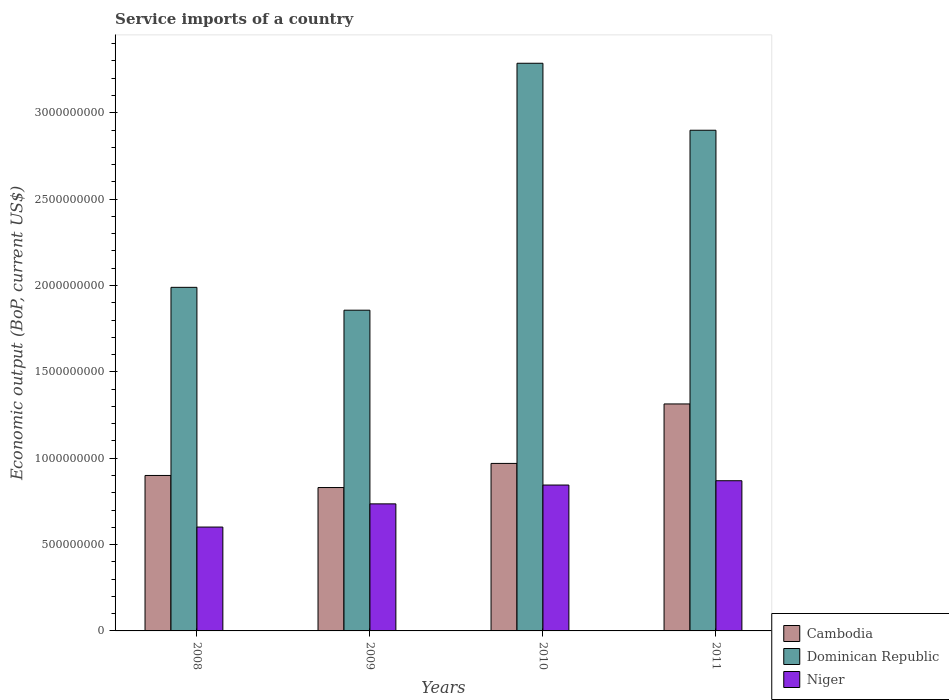How many groups of bars are there?
Make the answer very short. 4. Are the number of bars per tick equal to the number of legend labels?
Ensure brevity in your answer.  Yes. Are the number of bars on each tick of the X-axis equal?
Your answer should be very brief. Yes. How many bars are there on the 2nd tick from the left?
Provide a short and direct response. 3. How many bars are there on the 3rd tick from the right?
Your answer should be very brief. 3. What is the label of the 4th group of bars from the left?
Provide a succinct answer. 2011. What is the service imports in Dominican Republic in 2009?
Keep it short and to the point. 1.86e+09. Across all years, what is the maximum service imports in Dominican Republic?
Your response must be concise. 3.29e+09. Across all years, what is the minimum service imports in Niger?
Make the answer very short. 6.01e+08. In which year was the service imports in Dominican Republic maximum?
Provide a short and direct response. 2010. What is the total service imports in Dominican Republic in the graph?
Keep it short and to the point. 1.00e+1. What is the difference between the service imports in Dominican Republic in 2008 and that in 2009?
Keep it short and to the point. 1.32e+08. What is the difference between the service imports in Cambodia in 2011 and the service imports in Niger in 2009?
Ensure brevity in your answer.  5.79e+08. What is the average service imports in Dominican Republic per year?
Your answer should be compact. 2.51e+09. In the year 2011, what is the difference between the service imports in Cambodia and service imports in Niger?
Provide a short and direct response. 4.45e+08. In how many years, is the service imports in Niger greater than 1100000000 US$?
Make the answer very short. 0. What is the ratio of the service imports in Dominican Republic in 2008 to that in 2010?
Ensure brevity in your answer.  0.61. Is the difference between the service imports in Cambodia in 2008 and 2010 greater than the difference between the service imports in Niger in 2008 and 2010?
Provide a succinct answer. Yes. What is the difference between the highest and the second highest service imports in Dominican Republic?
Your answer should be very brief. 3.88e+08. What is the difference between the highest and the lowest service imports in Cambodia?
Provide a short and direct response. 4.84e+08. In how many years, is the service imports in Niger greater than the average service imports in Niger taken over all years?
Ensure brevity in your answer.  2. Is the sum of the service imports in Niger in 2009 and 2011 greater than the maximum service imports in Dominican Republic across all years?
Offer a terse response. No. What does the 1st bar from the left in 2009 represents?
Keep it short and to the point. Cambodia. What does the 3rd bar from the right in 2011 represents?
Make the answer very short. Cambodia. How many bars are there?
Offer a very short reply. 12. Are all the bars in the graph horizontal?
Give a very brief answer. No. How many years are there in the graph?
Your answer should be very brief. 4. Does the graph contain grids?
Make the answer very short. No. How many legend labels are there?
Your response must be concise. 3. How are the legend labels stacked?
Make the answer very short. Vertical. What is the title of the graph?
Keep it short and to the point. Service imports of a country. What is the label or title of the X-axis?
Give a very brief answer. Years. What is the label or title of the Y-axis?
Your answer should be very brief. Economic output (BoP, current US$). What is the Economic output (BoP, current US$) of Cambodia in 2008?
Your response must be concise. 9.00e+08. What is the Economic output (BoP, current US$) in Dominican Republic in 2008?
Provide a short and direct response. 1.99e+09. What is the Economic output (BoP, current US$) of Niger in 2008?
Offer a very short reply. 6.01e+08. What is the Economic output (BoP, current US$) of Cambodia in 2009?
Keep it short and to the point. 8.30e+08. What is the Economic output (BoP, current US$) of Dominican Republic in 2009?
Your answer should be compact. 1.86e+09. What is the Economic output (BoP, current US$) of Niger in 2009?
Make the answer very short. 7.36e+08. What is the Economic output (BoP, current US$) of Cambodia in 2010?
Make the answer very short. 9.70e+08. What is the Economic output (BoP, current US$) of Dominican Republic in 2010?
Your answer should be very brief. 3.29e+09. What is the Economic output (BoP, current US$) in Niger in 2010?
Provide a short and direct response. 8.45e+08. What is the Economic output (BoP, current US$) of Cambodia in 2011?
Your response must be concise. 1.31e+09. What is the Economic output (BoP, current US$) of Dominican Republic in 2011?
Make the answer very short. 2.90e+09. What is the Economic output (BoP, current US$) in Niger in 2011?
Give a very brief answer. 8.70e+08. Across all years, what is the maximum Economic output (BoP, current US$) of Cambodia?
Your answer should be compact. 1.31e+09. Across all years, what is the maximum Economic output (BoP, current US$) in Dominican Republic?
Ensure brevity in your answer.  3.29e+09. Across all years, what is the maximum Economic output (BoP, current US$) in Niger?
Offer a terse response. 8.70e+08. Across all years, what is the minimum Economic output (BoP, current US$) of Cambodia?
Ensure brevity in your answer.  8.30e+08. Across all years, what is the minimum Economic output (BoP, current US$) of Dominican Republic?
Offer a terse response. 1.86e+09. Across all years, what is the minimum Economic output (BoP, current US$) in Niger?
Your answer should be compact. 6.01e+08. What is the total Economic output (BoP, current US$) in Cambodia in the graph?
Offer a terse response. 4.01e+09. What is the total Economic output (BoP, current US$) of Dominican Republic in the graph?
Keep it short and to the point. 1.00e+1. What is the total Economic output (BoP, current US$) in Niger in the graph?
Offer a very short reply. 3.05e+09. What is the difference between the Economic output (BoP, current US$) in Cambodia in 2008 and that in 2009?
Your response must be concise. 6.99e+07. What is the difference between the Economic output (BoP, current US$) of Dominican Republic in 2008 and that in 2009?
Give a very brief answer. 1.32e+08. What is the difference between the Economic output (BoP, current US$) in Niger in 2008 and that in 2009?
Your response must be concise. -1.34e+08. What is the difference between the Economic output (BoP, current US$) in Cambodia in 2008 and that in 2010?
Ensure brevity in your answer.  -6.98e+07. What is the difference between the Economic output (BoP, current US$) in Dominican Republic in 2008 and that in 2010?
Offer a terse response. -1.30e+09. What is the difference between the Economic output (BoP, current US$) of Niger in 2008 and that in 2010?
Ensure brevity in your answer.  -2.43e+08. What is the difference between the Economic output (BoP, current US$) in Cambodia in 2008 and that in 2011?
Your answer should be compact. -4.14e+08. What is the difference between the Economic output (BoP, current US$) of Dominican Republic in 2008 and that in 2011?
Keep it short and to the point. -9.10e+08. What is the difference between the Economic output (BoP, current US$) of Niger in 2008 and that in 2011?
Your answer should be compact. -2.68e+08. What is the difference between the Economic output (BoP, current US$) of Cambodia in 2009 and that in 2010?
Keep it short and to the point. -1.40e+08. What is the difference between the Economic output (BoP, current US$) in Dominican Republic in 2009 and that in 2010?
Provide a succinct answer. -1.43e+09. What is the difference between the Economic output (BoP, current US$) of Niger in 2009 and that in 2010?
Give a very brief answer. -1.09e+08. What is the difference between the Economic output (BoP, current US$) in Cambodia in 2009 and that in 2011?
Make the answer very short. -4.84e+08. What is the difference between the Economic output (BoP, current US$) of Dominican Republic in 2009 and that in 2011?
Offer a very short reply. -1.04e+09. What is the difference between the Economic output (BoP, current US$) in Niger in 2009 and that in 2011?
Offer a very short reply. -1.34e+08. What is the difference between the Economic output (BoP, current US$) in Cambodia in 2010 and that in 2011?
Provide a succinct answer. -3.44e+08. What is the difference between the Economic output (BoP, current US$) in Dominican Republic in 2010 and that in 2011?
Give a very brief answer. 3.88e+08. What is the difference between the Economic output (BoP, current US$) in Niger in 2010 and that in 2011?
Offer a very short reply. -2.49e+07. What is the difference between the Economic output (BoP, current US$) in Cambodia in 2008 and the Economic output (BoP, current US$) in Dominican Republic in 2009?
Your answer should be very brief. -9.57e+08. What is the difference between the Economic output (BoP, current US$) of Cambodia in 2008 and the Economic output (BoP, current US$) of Niger in 2009?
Your response must be concise. 1.64e+08. What is the difference between the Economic output (BoP, current US$) of Dominican Republic in 2008 and the Economic output (BoP, current US$) of Niger in 2009?
Make the answer very short. 1.25e+09. What is the difference between the Economic output (BoP, current US$) of Cambodia in 2008 and the Economic output (BoP, current US$) of Dominican Republic in 2010?
Your answer should be compact. -2.39e+09. What is the difference between the Economic output (BoP, current US$) of Cambodia in 2008 and the Economic output (BoP, current US$) of Niger in 2010?
Provide a short and direct response. 5.54e+07. What is the difference between the Economic output (BoP, current US$) of Dominican Republic in 2008 and the Economic output (BoP, current US$) of Niger in 2010?
Your answer should be compact. 1.14e+09. What is the difference between the Economic output (BoP, current US$) in Cambodia in 2008 and the Economic output (BoP, current US$) in Dominican Republic in 2011?
Provide a short and direct response. -2.00e+09. What is the difference between the Economic output (BoP, current US$) in Cambodia in 2008 and the Economic output (BoP, current US$) in Niger in 2011?
Your answer should be compact. 3.05e+07. What is the difference between the Economic output (BoP, current US$) in Dominican Republic in 2008 and the Economic output (BoP, current US$) in Niger in 2011?
Make the answer very short. 1.12e+09. What is the difference between the Economic output (BoP, current US$) of Cambodia in 2009 and the Economic output (BoP, current US$) of Dominican Republic in 2010?
Keep it short and to the point. -2.46e+09. What is the difference between the Economic output (BoP, current US$) in Cambodia in 2009 and the Economic output (BoP, current US$) in Niger in 2010?
Your answer should be very brief. -1.45e+07. What is the difference between the Economic output (BoP, current US$) of Dominican Republic in 2009 and the Economic output (BoP, current US$) of Niger in 2010?
Provide a succinct answer. 1.01e+09. What is the difference between the Economic output (BoP, current US$) in Cambodia in 2009 and the Economic output (BoP, current US$) in Dominican Republic in 2011?
Provide a succinct answer. -2.07e+09. What is the difference between the Economic output (BoP, current US$) in Cambodia in 2009 and the Economic output (BoP, current US$) in Niger in 2011?
Offer a very short reply. -3.94e+07. What is the difference between the Economic output (BoP, current US$) of Dominican Republic in 2009 and the Economic output (BoP, current US$) of Niger in 2011?
Give a very brief answer. 9.87e+08. What is the difference between the Economic output (BoP, current US$) of Cambodia in 2010 and the Economic output (BoP, current US$) of Dominican Republic in 2011?
Offer a terse response. -1.93e+09. What is the difference between the Economic output (BoP, current US$) in Cambodia in 2010 and the Economic output (BoP, current US$) in Niger in 2011?
Give a very brief answer. 1.00e+08. What is the difference between the Economic output (BoP, current US$) in Dominican Republic in 2010 and the Economic output (BoP, current US$) in Niger in 2011?
Offer a terse response. 2.42e+09. What is the average Economic output (BoP, current US$) of Cambodia per year?
Provide a short and direct response. 1.00e+09. What is the average Economic output (BoP, current US$) in Dominican Republic per year?
Provide a succinct answer. 2.51e+09. What is the average Economic output (BoP, current US$) in Niger per year?
Keep it short and to the point. 7.63e+08. In the year 2008, what is the difference between the Economic output (BoP, current US$) of Cambodia and Economic output (BoP, current US$) of Dominican Republic?
Ensure brevity in your answer.  -1.09e+09. In the year 2008, what is the difference between the Economic output (BoP, current US$) of Cambodia and Economic output (BoP, current US$) of Niger?
Offer a very short reply. 2.99e+08. In the year 2008, what is the difference between the Economic output (BoP, current US$) in Dominican Republic and Economic output (BoP, current US$) in Niger?
Your response must be concise. 1.39e+09. In the year 2009, what is the difference between the Economic output (BoP, current US$) of Cambodia and Economic output (BoP, current US$) of Dominican Republic?
Offer a terse response. -1.03e+09. In the year 2009, what is the difference between the Economic output (BoP, current US$) of Cambodia and Economic output (BoP, current US$) of Niger?
Make the answer very short. 9.46e+07. In the year 2009, what is the difference between the Economic output (BoP, current US$) of Dominican Republic and Economic output (BoP, current US$) of Niger?
Offer a very short reply. 1.12e+09. In the year 2010, what is the difference between the Economic output (BoP, current US$) in Cambodia and Economic output (BoP, current US$) in Dominican Republic?
Keep it short and to the point. -2.32e+09. In the year 2010, what is the difference between the Economic output (BoP, current US$) in Cambodia and Economic output (BoP, current US$) in Niger?
Your answer should be compact. 1.25e+08. In the year 2010, what is the difference between the Economic output (BoP, current US$) in Dominican Republic and Economic output (BoP, current US$) in Niger?
Provide a short and direct response. 2.44e+09. In the year 2011, what is the difference between the Economic output (BoP, current US$) of Cambodia and Economic output (BoP, current US$) of Dominican Republic?
Keep it short and to the point. -1.58e+09. In the year 2011, what is the difference between the Economic output (BoP, current US$) of Cambodia and Economic output (BoP, current US$) of Niger?
Keep it short and to the point. 4.45e+08. In the year 2011, what is the difference between the Economic output (BoP, current US$) in Dominican Republic and Economic output (BoP, current US$) in Niger?
Keep it short and to the point. 2.03e+09. What is the ratio of the Economic output (BoP, current US$) of Cambodia in 2008 to that in 2009?
Give a very brief answer. 1.08. What is the ratio of the Economic output (BoP, current US$) in Dominican Republic in 2008 to that in 2009?
Your answer should be very brief. 1.07. What is the ratio of the Economic output (BoP, current US$) in Niger in 2008 to that in 2009?
Make the answer very short. 0.82. What is the ratio of the Economic output (BoP, current US$) in Cambodia in 2008 to that in 2010?
Provide a succinct answer. 0.93. What is the ratio of the Economic output (BoP, current US$) in Dominican Republic in 2008 to that in 2010?
Make the answer very short. 0.61. What is the ratio of the Economic output (BoP, current US$) of Niger in 2008 to that in 2010?
Your answer should be very brief. 0.71. What is the ratio of the Economic output (BoP, current US$) of Cambodia in 2008 to that in 2011?
Ensure brevity in your answer.  0.68. What is the ratio of the Economic output (BoP, current US$) in Dominican Republic in 2008 to that in 2011?
Make the answer very short. 0.69. What is the ratio of the Economic output (BoP, current US$) in Niger in 2008 to that in 2011?
Your answer should be very brief. 0.69. What is the ratio of the Economic output (BoP, current US$) of Cambodia in 2009 to that in 2010?
Keep it short and to the point. 0.86. What is the ratio of the Economic output (BoP, current US$) in Dominican Republic in 2009 to that in 2010?
Your response must be concise. 0.56. What is the ratio of the Economic output (BoP, current US$) of Niger in 2009 to that in 2010?
Your answer should be very brief. 0.87. What is the ratio of the Economic output (BoP, current US$) of Cambodia in 2009 to that in 2011?
Keep it short and to the point. 0.63. What is the ratio of the Economic output (BoP, current US$) of Dominican Republic in 2009 to that in 2011?
Provide a succinct answer. 0.64. What is the ratio of the Economic output (BoP, current US$) in Niger in 2009 to that in 2011?
Keep it short and to the point. 0.85. What is the ratio of the Economic output (BoP, current US$) of Cambodia in 2010 to that in 2011?
Provide a short and direct response. 0.74. What is the ratio of the Economic output (BoP, current US$) of Dominican Republic in 2010 to that in 2011?
Keep it short and to the point. 1.13. What is the ratio of the Economic output (BoP, current US$) in Niger in 2010 to that in 2011?
Provide a succinct answer. 0.97. What is the difference between the highest and the second highest Economic output (BoP, current US$) of Cambodia?
Offer a terse response. 3.44e+08. What is the difference between the highest and the second highest Economic output (BoP, current US$) of Dominican Republic?
Make the answer very short. 3.88e+08. What is the difference between the highest and the second highest Economic output (BoP, current US$) in Niger?
Provide a succinct answer. 2.49e+07. What is the difference between the highest and the lowest Economic output (BoP, current US$) in Cambodia?
Give a very brief answer. 4.84e+08. What is the difference between the highest and the lowest Economic output (BoP, current US$) of Dominican Republic?
Keep it short and to the point. 1.43e+09. What is the difference between the highest and the lowest Economic output (BoP, current US$) of Niger?
Provide a succinct answer. 2.68e+08. 